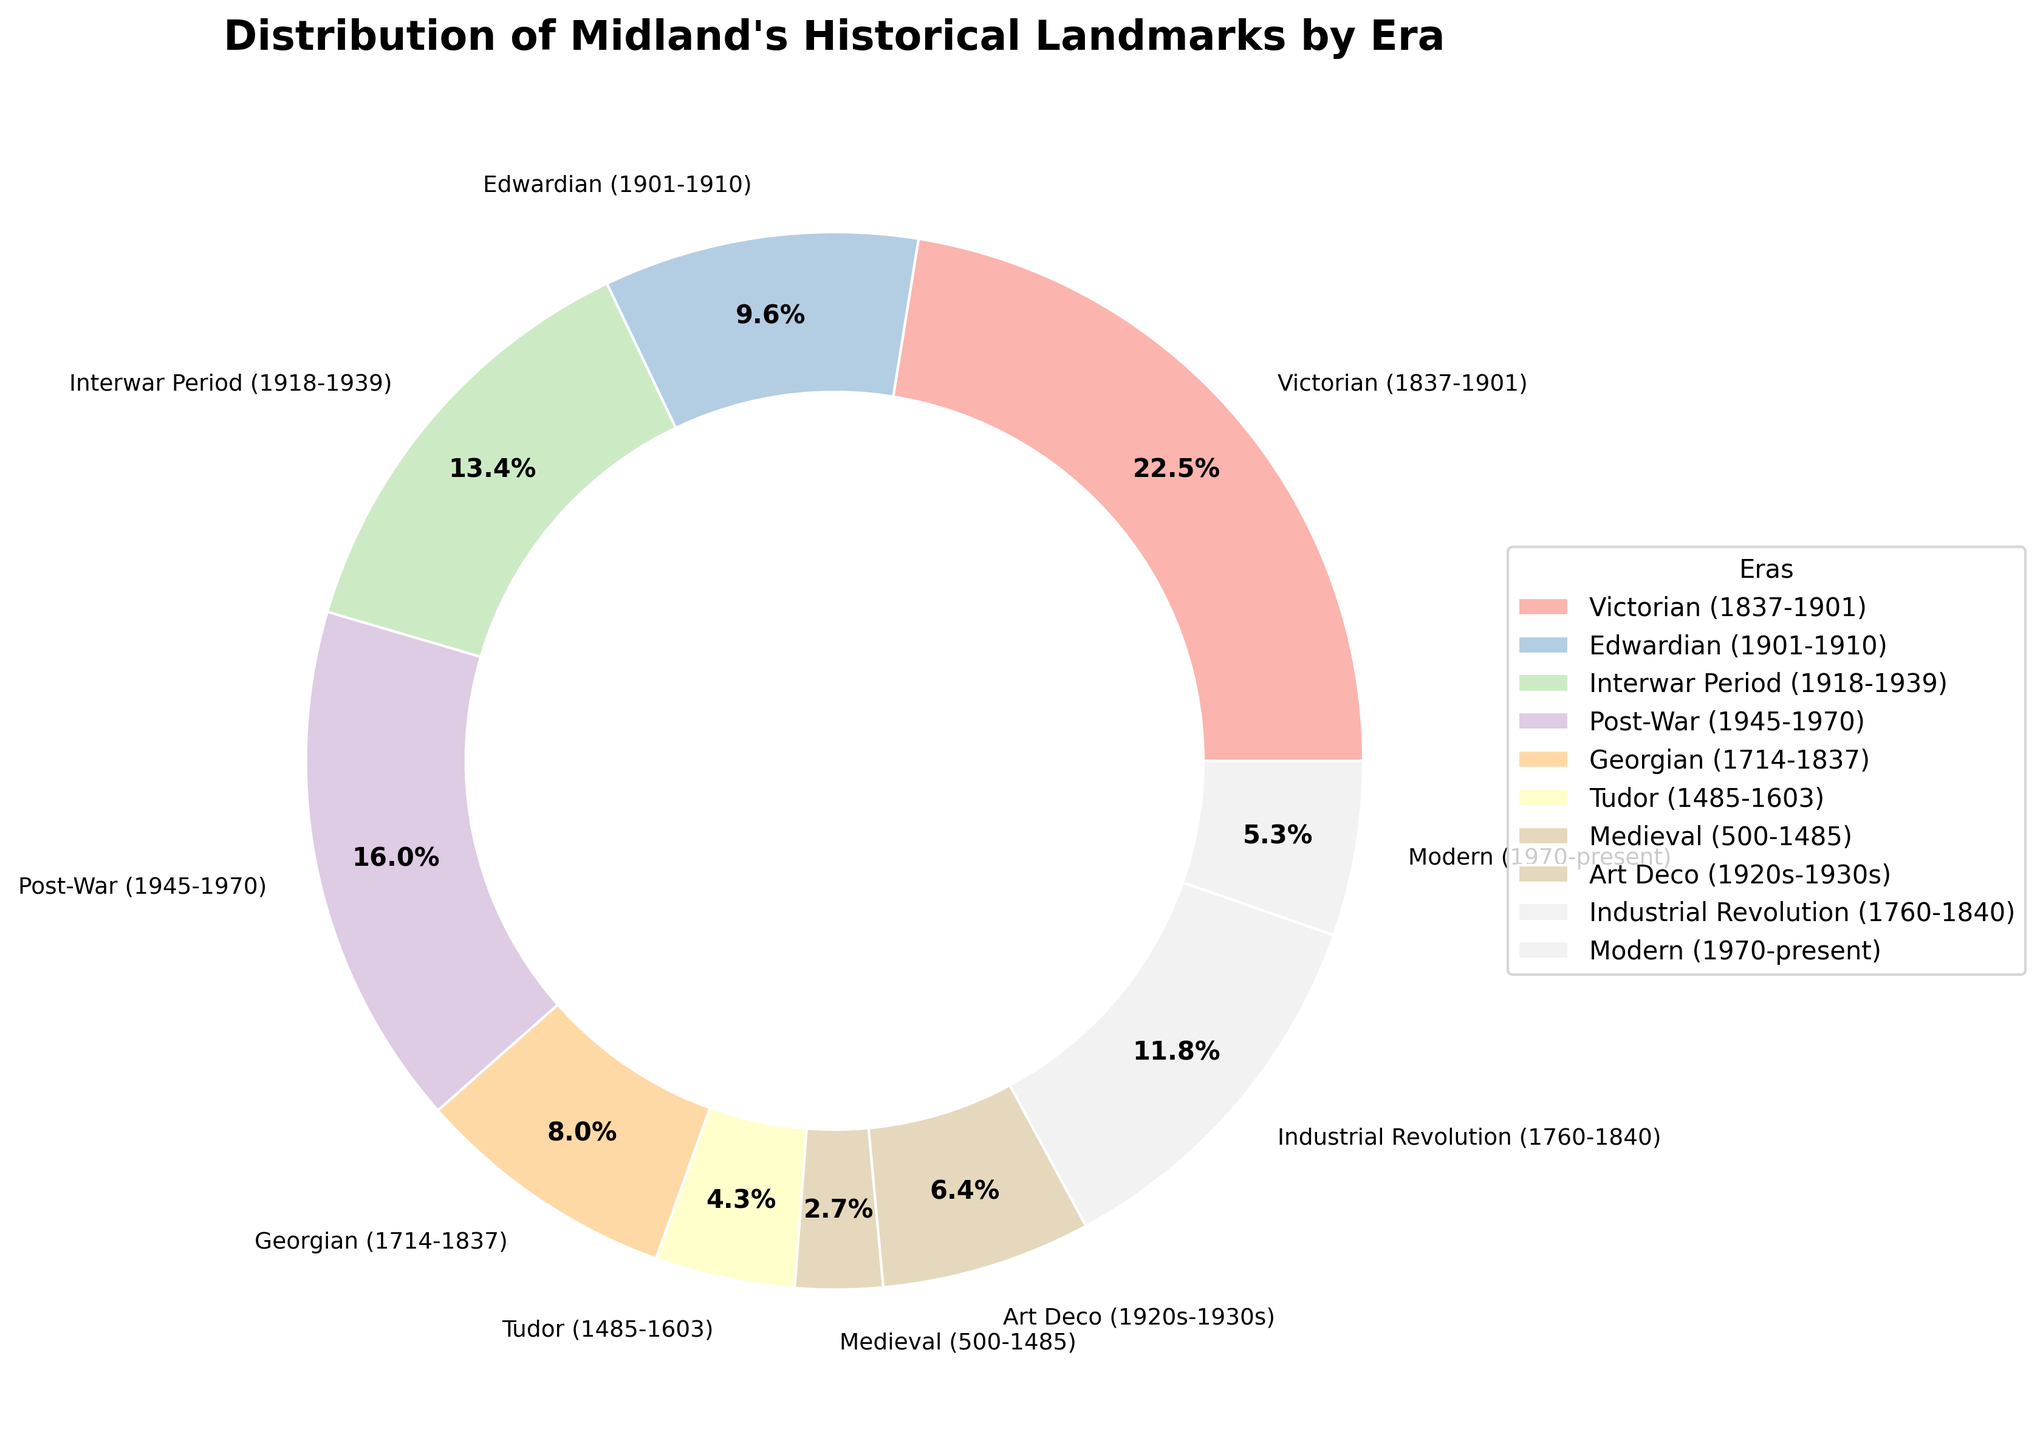What's the era with the highest number of historical landmarks? The pie chart shows the Victorian era has the largest section.
Answer: Victorian (1837-1901) Which era has fewer historical landmarks, the Tudor or the Georgian period? By visually comparing the sizes of the pie chart segments, the Tudor era segment is smaller than the Georgian segment.
Answer: Tudor (1485-1603) Combine the total number of landmarks from the Interwar Period and the Art Deco era. The chart indicates 25 landmarks for the Interwar Period and 12 for the Art Deco era. The sum is 25 + 12.
Answer: 37 What's the combined percentage of historical landmarks from the Edwardian and Medieval periods? The chart shows that the Edwardian era has 18 landmarks, and the Medieval era has 5. Adding these two gives 23 landmarks. Calculate the percentage: (18 + 5) / total landmarks * 100%. [(18 + 5) / 187 * 100 = 12.3%]
Answer: 12.3% Compare the landmarks from the Post-War period to those from the Modern era. The chart indicates 30 landmarks for the Post-War period and 10 for the Modern era. The Post-War period has more landmarks.
Answer: Post-War (1945-1970) Which segment visually appears the smallest? The smallest color segment in the pie chart represents the Medieval period.
Answer: Medieval (500-1485) What percentage of landmarks are from the Industrial Revolution? The chart indicates the Industrial Revolution has 22 landmarks. Calculate the percentage: 22 / total landmarks * 100%. [22 / 187 * 100 = 11.8%]
Answer: 11.8% If we combine the landmarks from the Victorian and Georgian periods, what percentage of the total landmarks would they represent? The chart shows 42 landmarks for the Victorian era and 15 for the Georgian era. Combined, they total 57 landmarks. Calculate the percentage: 57 / total landmarks * 100%. [57 / 187 * 100 = 30.5%]
Answer: 30.5% How does the number of landmarks from the Art Deco era compare to those from the Edwardian period? The chart indicates the Art Deco era has 12 landmarks, while the Edwardian period has 18. The Edwardian period has more landmarks.
Answer: Edwardian (1901-1910) What is the difference in the number of landmarks between the Post-War and Industrial Revolution eras? The chart indicates 30 landmarks for the Post-War period and 22 landmarks for the Industrial Revolution. The difference is 30 - 22.
Answer: 8 